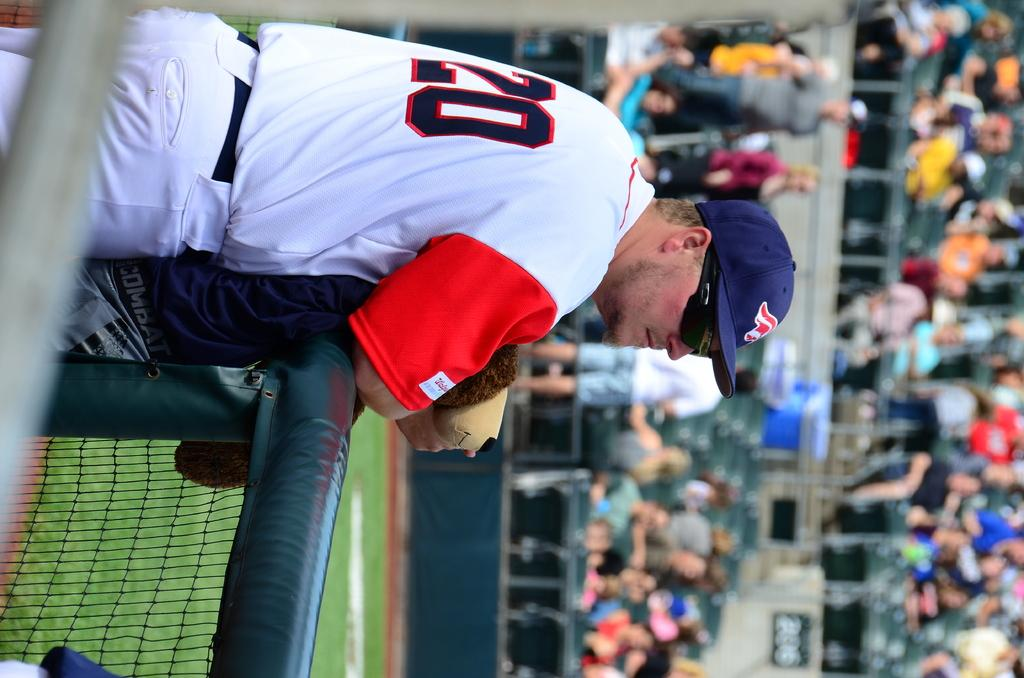<image>
Give a short and clear explanation of the subsequent image. The sideways photo of a baseball player in the dugout with a walgreen's patch on his sleeve. 